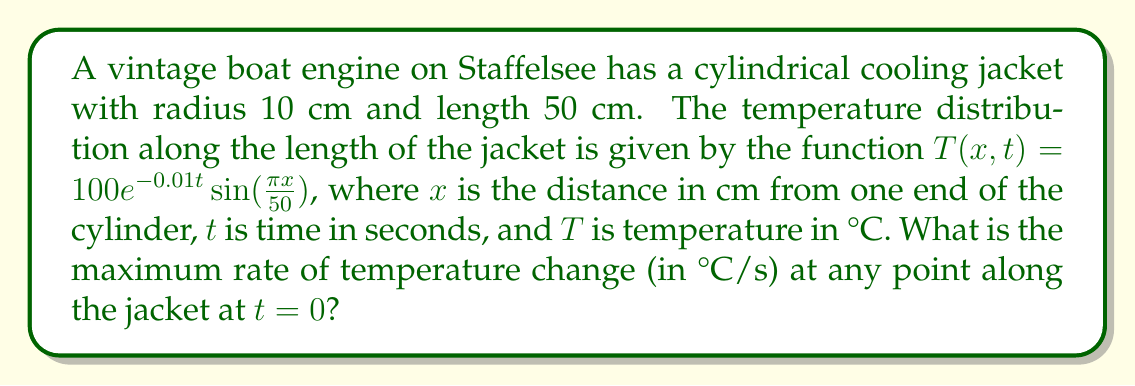Show me your answer to this math problem. To solve this problem, we need to follow these steps:

1) The temperature distribution is given by:
   $$T(x,t) = 100e^{-0.01t}\sin(\frac{\pi x}{50})$$

2) To find the rate of temperature change, we need to take the partial derivative with respect to time:
   $$\frac{\partial T}{\partial t} = -0.01 \cdot 100e^{-0.01t}\sin(\frac{\pi x}{50})$$

3) At $t = 0$, this simplifies to:
   $$\frac{\partial T}{\partial t} = -\sin(\frac{\pi x}{50})$$

4) The maximum absolute value of sine is 1, which occurs when its argument is $\frac{\pi}{2}$ or $\frac{3\pi}{2}$.

5) Therefore, the maximum rate of temperature change (in absolute value) is:
   $$|-\sin(\frac{\pi x}{50})| = 1$$

6) The negative sign indicates that the temperature is decreasing at its maximum rate.

Thus, the maximum rate of temperature change at any point along the jacket at $t = 0$ is 1°C/s (decreasing).
Answer: 1°C/s 